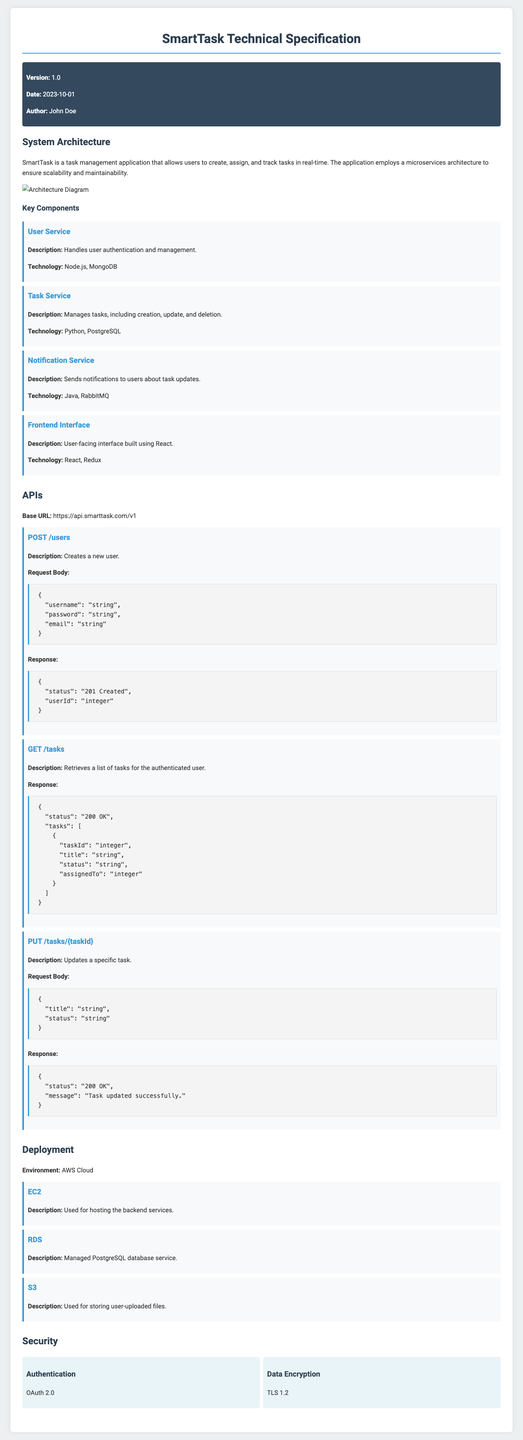what is the version of the document? The version of the document is indicated in the metadata section.
Answer: 1.0 who is the author of the document? The author name is listed in the metadata section of the document.
Answer: John Doe what technology does the User Service use? The technology for the User Service is specified under the Key Components section.
Answer: Node.js, MongoDB what is the base URL for the APIs? The base URL is provided in the APIs section of the document.
Answer: https://api.smarttask.com/v1 how many key components are described in the document? The number of key components can be counted from the listed components in the System Architecture section.
Answer: 4 which service is responsible for user authentication? The service responsible for user authentication is mentioned in the Key Components section.
Answer: User Service what is the description of the Notification Service? The description is provided in the Key Components section.
Answer: Sends notifications to users about task updates which encryption standard is mentioned for data encryption? The encryption standard is specified in the Security section of the document.
Answer: TLS 1.2 what is the environment used for deployment? The deployment environment is indicated in the Deployment section.
Answer: AWS Cloud 